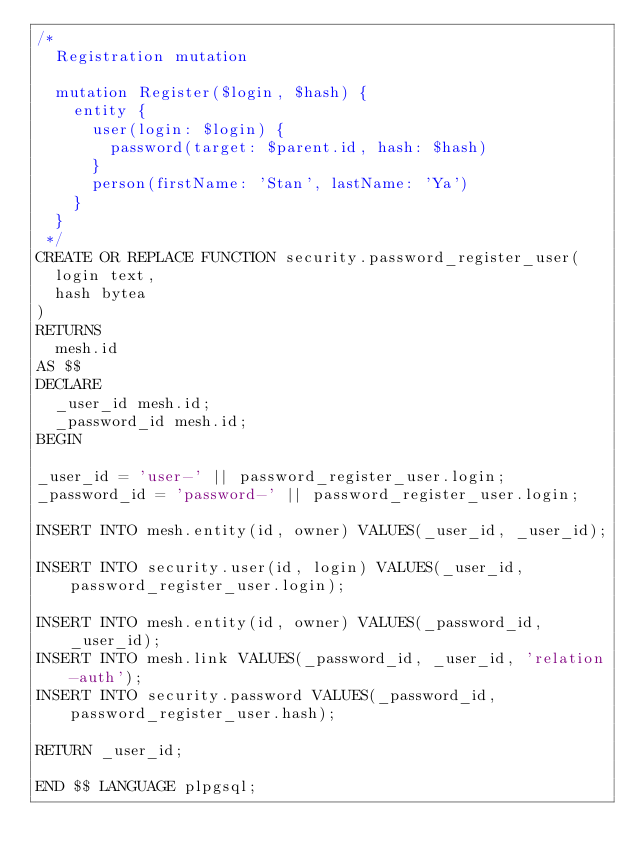<code> <loc_0><loc_0><loc_500><loc_500><_SQL_>/*
  Registration mutation

  mutation Register($login, $hash) {
    entity {
      user(login: $login) {
        password(target: $parent.id, hash: $hash)
      }
      person(firstName: 'Stan', lastName: 'Ya')
    }
  }
 */
CREATE OR REPLACE FUNCTION security.password_register_user(
  login text,
  hash bytea
)
RETURNS
  mesh.id
AS $$
DECLARE
  _user_id mesh.id;
  _password_id mesh.id;
BEGIN

_user_id = 'user-' || password_register_user.login;
_password_id = 'password-' || password_register_user.login;

INSERT INTO mesh.entity(id, owner) VALUES(_user_id, _user_id);

INSERT INTO security.user(id, login) VALUES(_user_id, password_register_user.login);

INSERT INTO mesh.entity(id, owner) VALUES(_password_id, _user_id);
INSERT INTO mesh.link VALUES(_password_id, _user_id, 'relation-auth');
INSERT INTO security.password VALUES(_password_id, password_register_user.hash);

RETURN _user_id;

END $$ LANGUAGE plpgsql;
</code> 